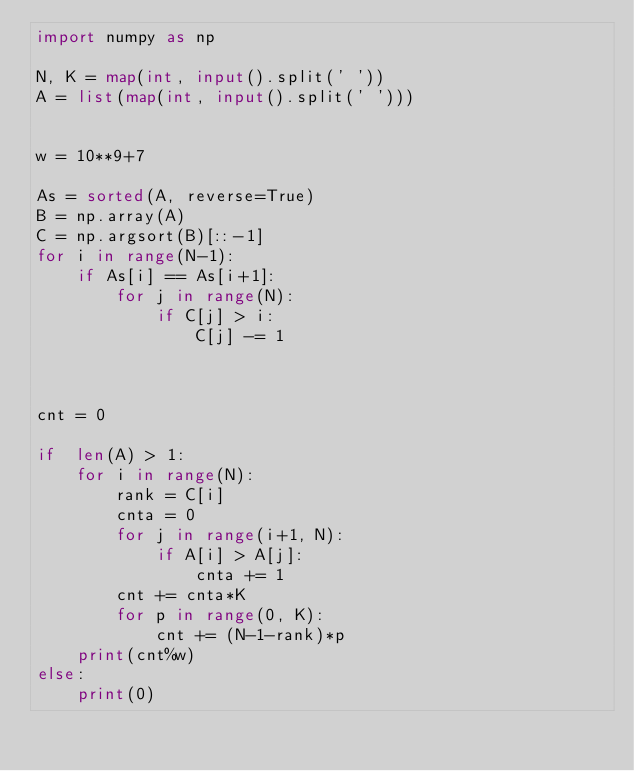Convert code to text. <code><loc_0><loc_0><loc_500><loc_500><_Python_>import numpy as np

N, K = map(int, input().split(' '))
A = list(map(int, input().split(' ')))


w = 10**9+7

As = sorted(A, reverse=True)
B = np.array(A)
C = np.argsort(B)[::-1]
for i in range(N-1):
    if As[i] == As[i+1]:
        for j in range(N):
            if C[j] > i:
                C[j] -= 1
        
        

cnt = 0

if  len(A) > 1:
    for i in range(N):
        rank = C[i]
        cnta = 0
        for j in range(i+1, N):
            if A[i] > A[j]:
                cnta += 1
        cnt += cnta*K
        for p in range(0, K):
            cnt += (N-1-rank)*p
    print(cnt%w)
else:
    print(0)</code> 